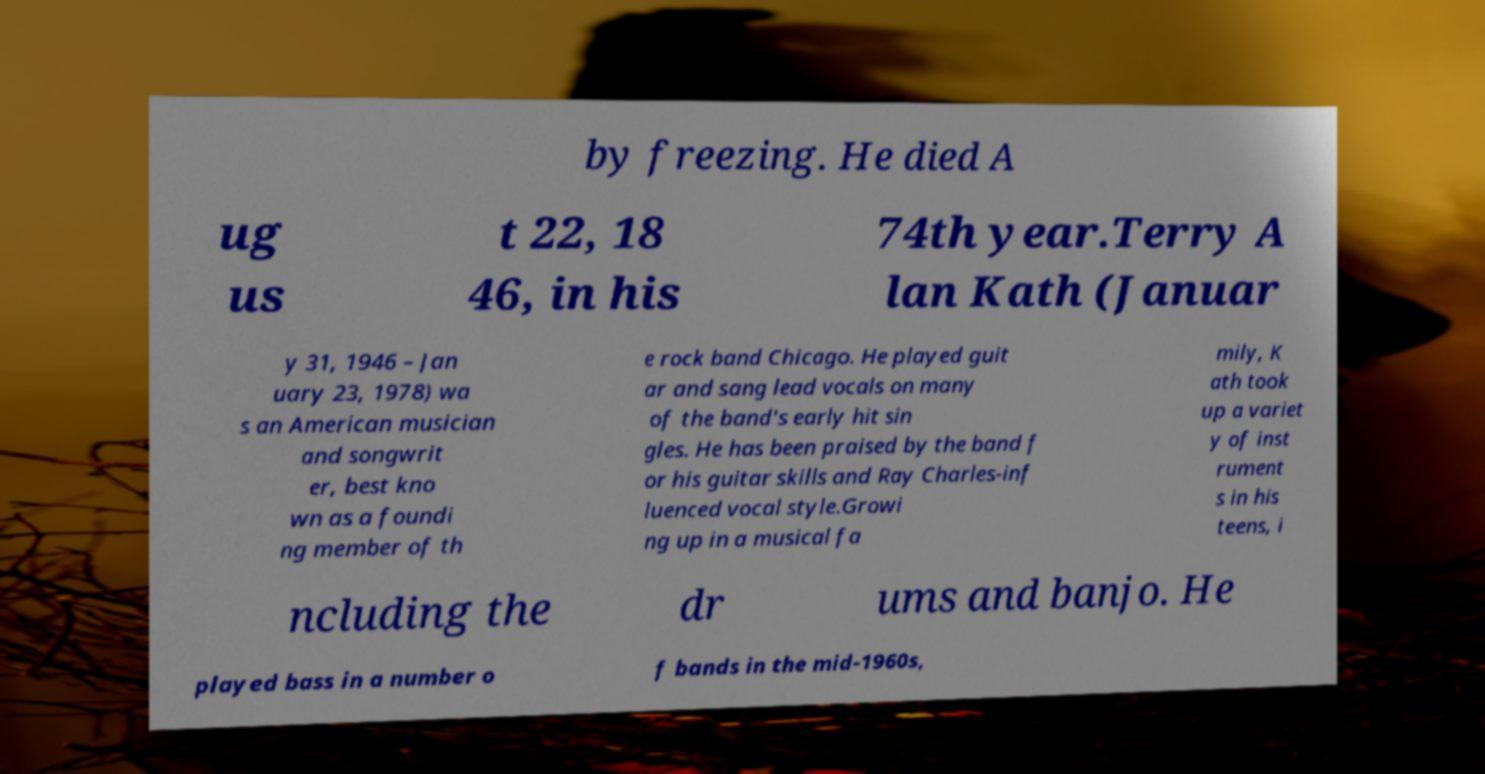What messages or text are displayed in this image? I need them in a readable, typed format. by freezing. He died A ug us t 22, 18 46, in his 74th year.Terry A lan Kath (Januar y 31, 1946 – Jan uary 23, 1978) wa s an American musician and songwrit er, best kno wn as a foundi ng member of th e rock band Chicago. He played guit ar and sang lead vocals on many of the band's early hit sin gles. He has been praised by the band f or his guitar skills and Ray Charles-inf luenced vocal style.Growi ng up in a musical fa mily, K ath took up a variet y of inst rument s in his teens, i ncluding the dr ums and banjo. He played bass in a number o f bands in the mid-1960s, 